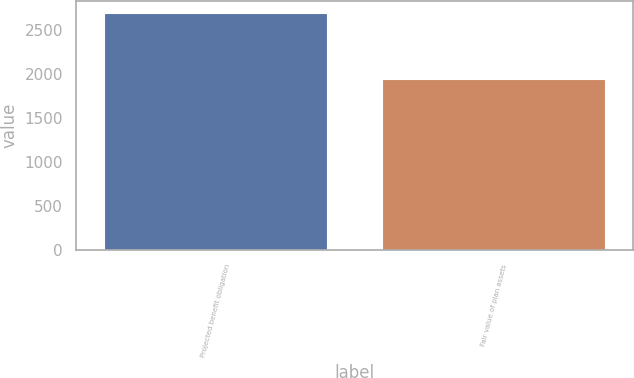Convert chart to OTSL. <chart><loc_0><loc_0><loc_500><loc_500><bar_chart><fcel>Projected benefit obligation<fcel>Fair value of plan assets<nl><fcel>2697<fcel>1942<nl></chart> 